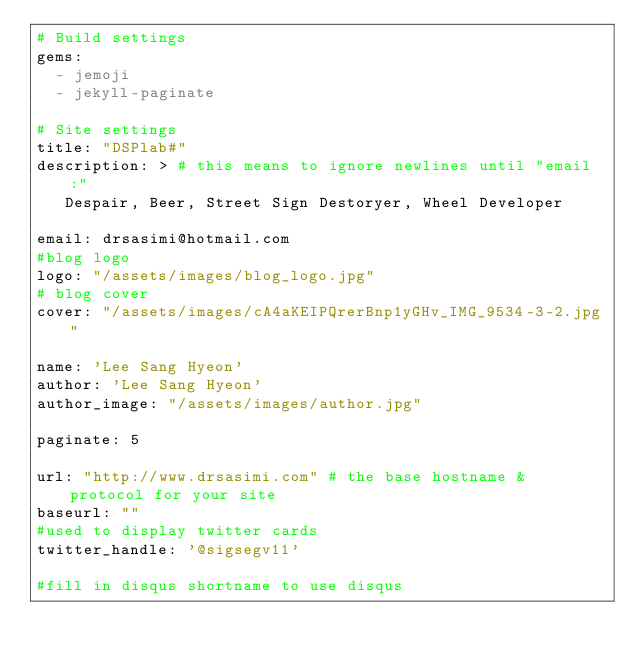<code> <loc_0><loc_0><loc_500><loc_500><_YAML_># Build settings
gems:
  - jemoji
  - jekyll-paginate

# Site settings
title: "DSPlab#"
description: > # this means to ignore newlines until "email:"
   Despair, Beer, Street Sign Destoryer, Wheel Developer

email: drsasimi@hotmail.com
#blog logo
logo: "/assets/images/blog_logo.jpg"
# blog cover
cover: "/assets/images/cA4aKEIPQrerBnp1yGHv_IMG_9534-3-2.jpg"

name: 'Lee Sang Hyeon'
author: 'Lee Sang Hyeon'
author_image: "/assets/images/author.jpg"

paginate:	5

url: "http://www.drsasimi.com" # the base hostname & protocol for your site
baseurl: ""
#used to display twitter cards
twitter_handle: '@sigsegv11'

#fill in disqus shortname to use disqus</code> 